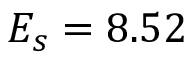Convert formula to latex. <formula><loc_0><loc_0><loc_500><loc_500>E _ { s } = 8 . 5 2 \</formula> 